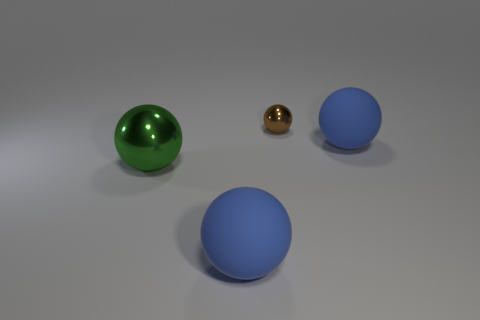What is the approximate size relationship between the spheres? The green sphere on the left appears to be the largest, followed by the blue spheres which seem to be of equal size and slightly smaller than the green one. The gold sphere is considerably smaller than the others. Is there anything that indicates scale or context for these objects? The image doesn't provide explicit context for scale, such as recognizable objects or a background environment. Therefore, we can only compare the sizes of the spheres relative to each other. 